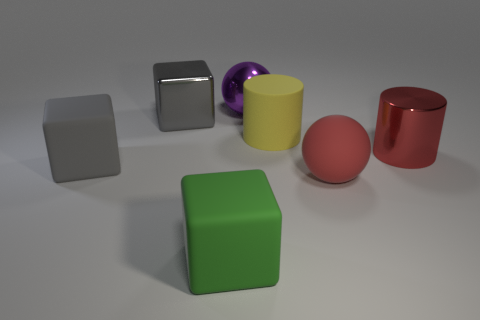What is the color of the metal block that is the same size as the yellow thing? gray 